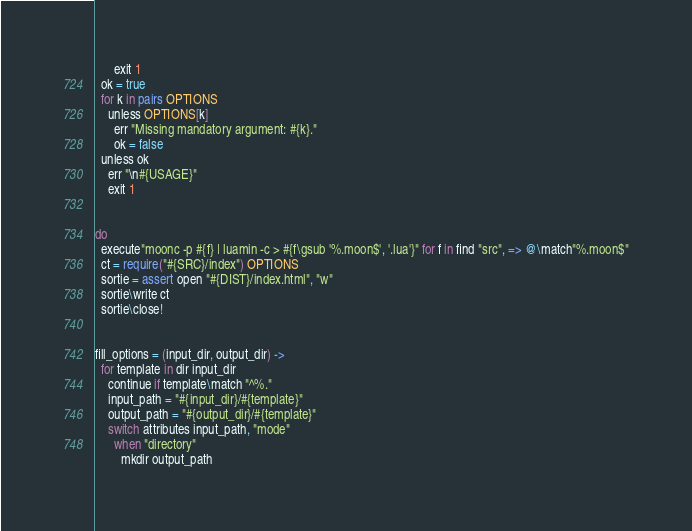Convert code to text. <code><loc_0><loc_0><loc_500><loc_500><_MoonScript_>      exit 1
  ok = true
  for k in pairs OPTIONS
    unless OPTIONS[k]
      err "Missing mandatory argument: #{k}."
      ok = false
  unless ok
    err "\n#{USAGE}"
    exit 1


do
  execute"moonc -p #{f} | luamin -c > #{f\gsub '%.moon$', '.lua'}" for f in find "src", => @\match"%.moon$"
  ct = require("#{SRC}/index") OPTIONS
  sortie = assert open "#{DIST}/index.html", "w"
  sortie\write ct
  sortie\close!


fill_options = (input_dir, output_dir) ->
  for template in dir input_dir
    continue if template\match "^%."
    input_path = "#{input_dir}/#{template}"
    output_path = "#{output_dir}/#{template}"
    switch attributes input_path, "mode"
      when "directory"
        mkdir output_path</code> 